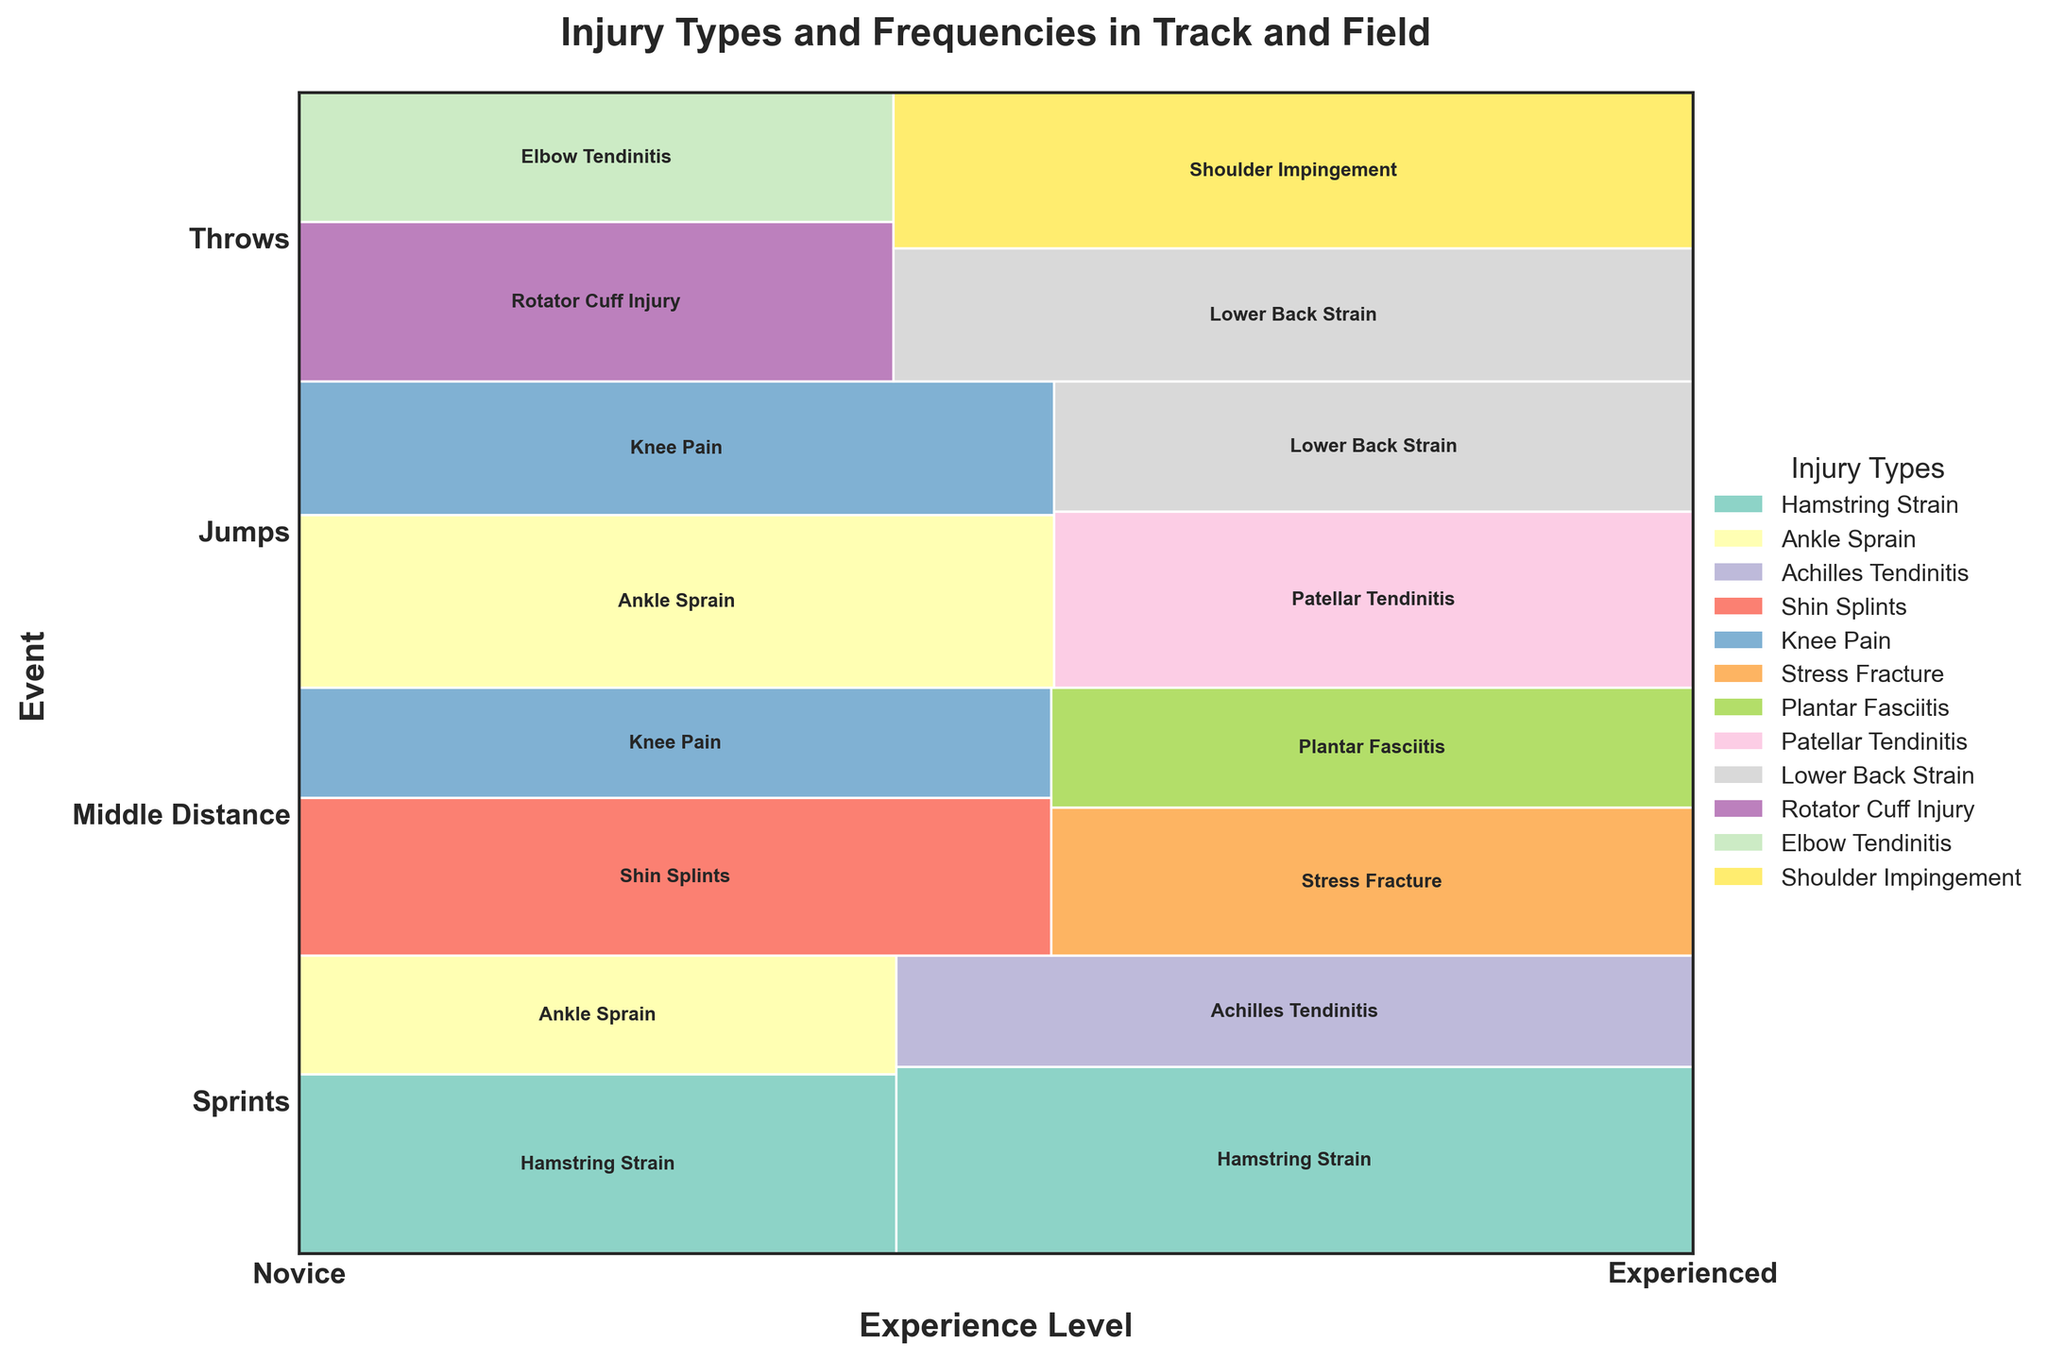What is the title of the figure? The title of the figure is usually found at the top of the plot. It's a text label that provides a summary of what the figure is about.
Answer: Injury Types and Frequencies in Track and Field Which event has the highest frequency of injuries for novice athletes? To determine this, we should look at the bottom half of the mosaic plot under the "Novice" column and compare the sizes of the sections for each event. The larger the section, the higher the frequency of injuries.
Answer: Jumps What is the most common injury type for experienced sprint athletes? We need to look at the section of the plot corresponding to "Sprints" and "Experienced" and identify which injury occupies the largest proportion within that section.
Answer: Hamstring Strain How does the frequency of hamstring strains in novice sprint athletes compare to experienced sprint athletes? To answer this, examine the respective areas for "Hamstring Strain" under novice and experienced sprint athletes. Compare the sizes of these sections to determine which is larger.
Answer: Experienced sprint athletes have a higher frequency of hamstring strains Which injury type is specific to both novice and experienced throw athletes but not observed in the other events? We need to identify the injury types present in both novice and experienced throw athletes, and then check if those types do not appear in the sections for other events.
Answer: Lower Back Strain What is the proportion of shin splints among novice middle-distance athletes? First, find the section for "Shin Splints" within the novice middle-distance category. Then, compare the area of this section to the total area for all injuries in novice middle-distance athletes.
Answer: 20/34 Are ankle sprains more common in novice jump athletes or novice sprint athletes? Look at the sections for “Ankle Sprain” under novice jump and novice sprint athletes and compare their sizes. The larger section indicates where ankle sprains are more common.
Answer: Novice jump athletes Which event has the lowest frequency of injuries for experienced athletes? Compare the cumulative heights of the sections under the "Experienced" columns for each event. The event with the smallest combined height has the lowest injury frequency.
Answer: Middle Distance How does the total frequency of injuries in throws compare between novice and experienced athletes? Sum the frequencies of all injury types for both novice and experienced throw athletes and compare the totals.
Answer: Experienced athletes have more injuries What are the two least common injury types across all events and experience levels combined? Identify the two smallest segments across the entire mosaic plot. These segments represent the least common injury types.
Answer: Achilles Tendinitis and Elbow Tendinitis 